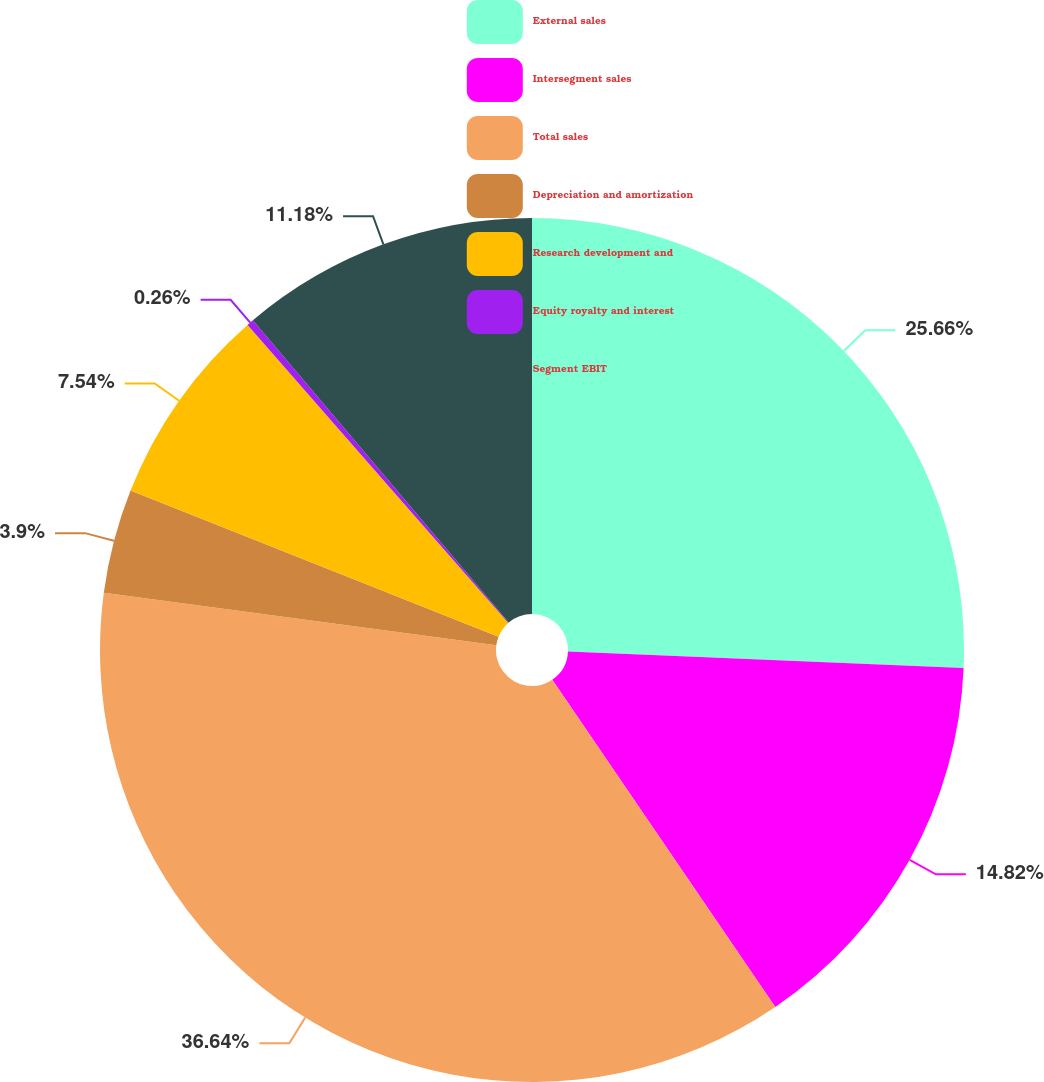Convert chart to OTSL. <chart><loc_0><loc_0><loc_500><loc_500><pie_chart><fcel>External sales<fcel>Intersegment sales<fcel>Total sales<fcel>Depreciation and amortization<fcel>Research development and<fcel>Equity royalty and interest<fcel>Segment EBIT<nl><fcel>25.66%<fcel>14.82%<fcel>36.64%<fcel>3.9%<fcel>7.54%<fcel>0.26%<fcel>11.18%<nl></chart> 